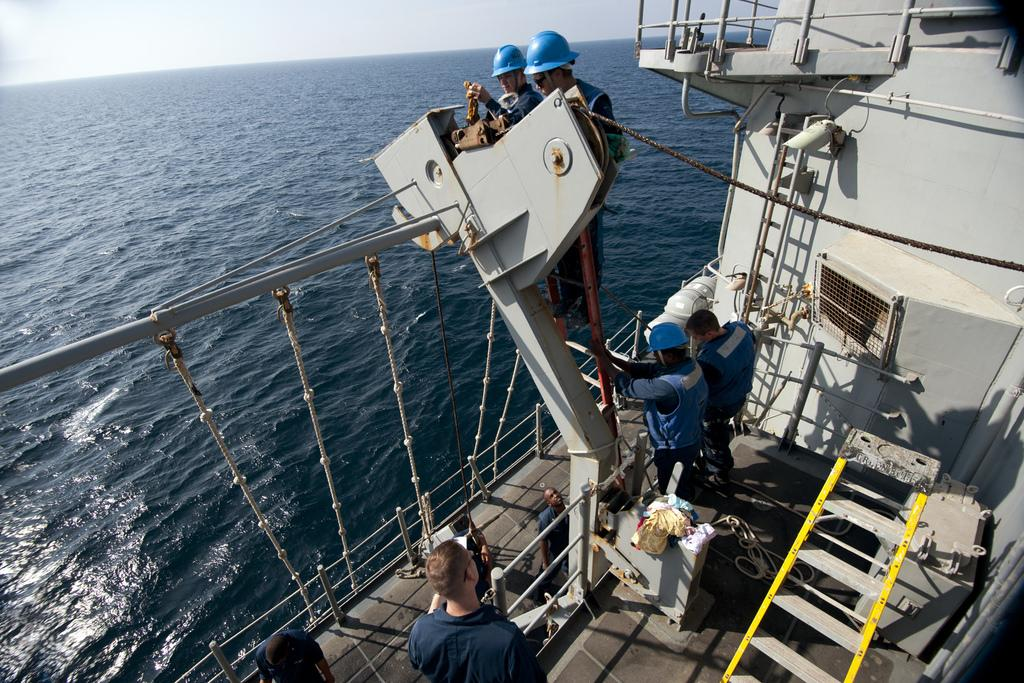What type of structure is visible in the image? There is a deck in the image. Where are the people located in the image? The people are at the bottom side of the image. What can be seen on the left side of the image? There is water on the left side of the image. What type of coat is hanging on the deck in the image? There is no coat present in the image. What type of brass instrument is being played by the people in the image? There is no brass instrument or indication of musical activity in the image. 